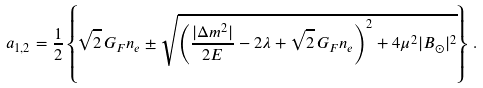<formula> <loc_0><loc_0><loc_500><loc_500>a _ { 1 , 2 } = \frac { 1 } { 2 } \left \{ \sqrt { 2 } \, G _ { F } n _ { e } \pm \sqrt { \left ( \frac { | \Delta m ^ { 2 } | } { 2 E } - 2 \lambda + \sqrt { 2 } \, G _ { F } n _ { e } \right ) ^ { 2 } + 4 \mu ^ { 2 } | B _ { \odot } | ^ { 2 } } \right \} \, .</formula> 